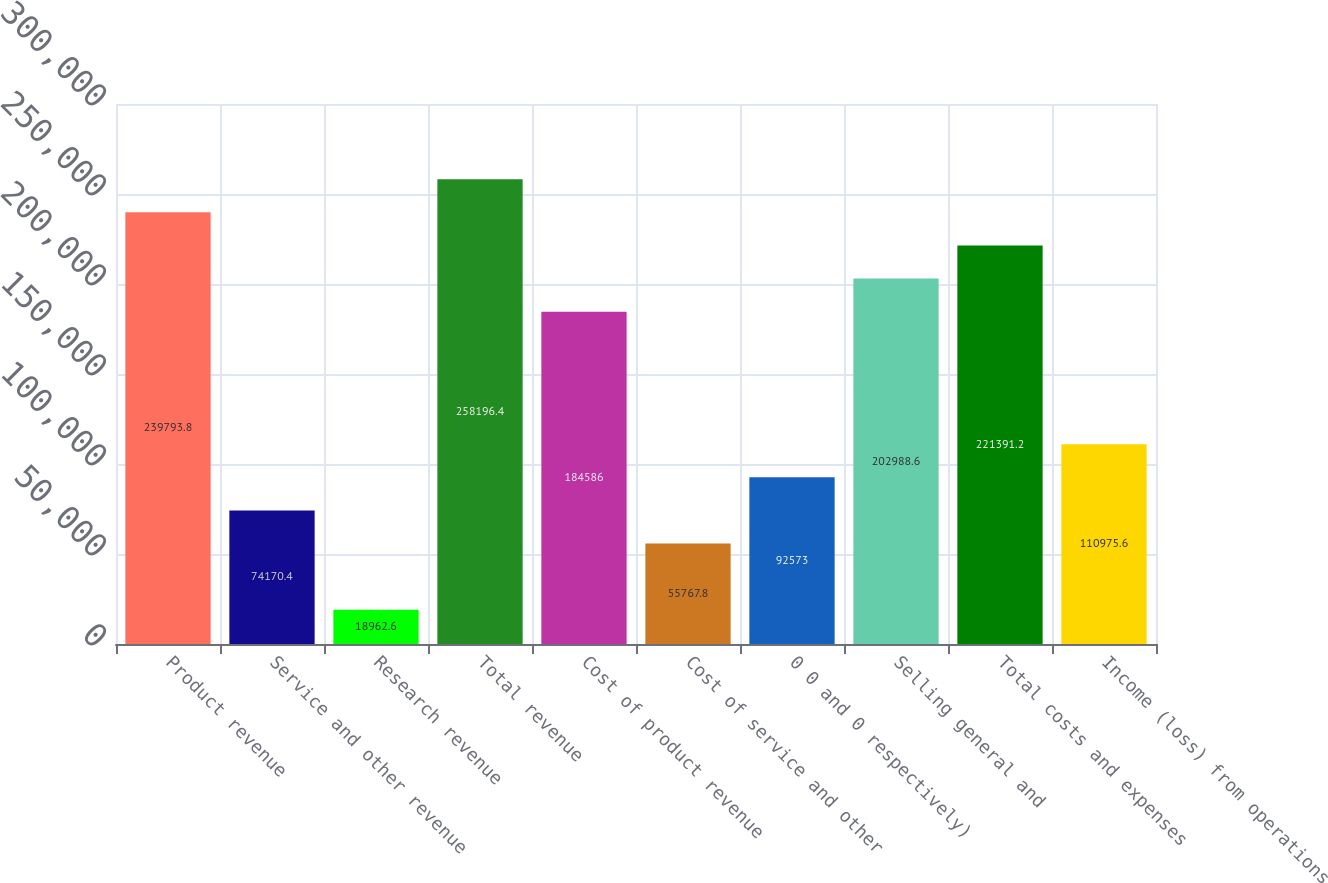<chart> <loc_0><loc_0><loc_500><loc_500><bar_chart><fcel>Product revenue<fcel>Service and other revenue<fcel>Research revenue<fcel>Total revenue<fcel>Cost of product revenue<fcel>Cost of service and other<fcel>0 0 and 0 respectively)<fcel>Selling general and<fcel>Total costs and expenses<fcel>Income (loss) from operations<nl><fcel>239794<fcel>74170.4<fcel>18962.6<fcel>258196<fcel>184586<fcel>55767.8<fcel>92573<fcel>202989<fcel>221391<fcel>110976<nl></chart> 